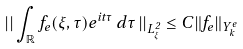Convert formula to latex. <formula><loc_0><loc_0><loc_500><loc_500>\left | \right | \int _ { \mathbb { R } } f _ { e } ( \xi , \tau ) e ^ { i t \tau } \, d \tau \left | \right | _ { L ^ { 2 } _ { \xi } } \leq C \| f _ { e } \| _ { Y _ { k } ^ { e } }</formula> 